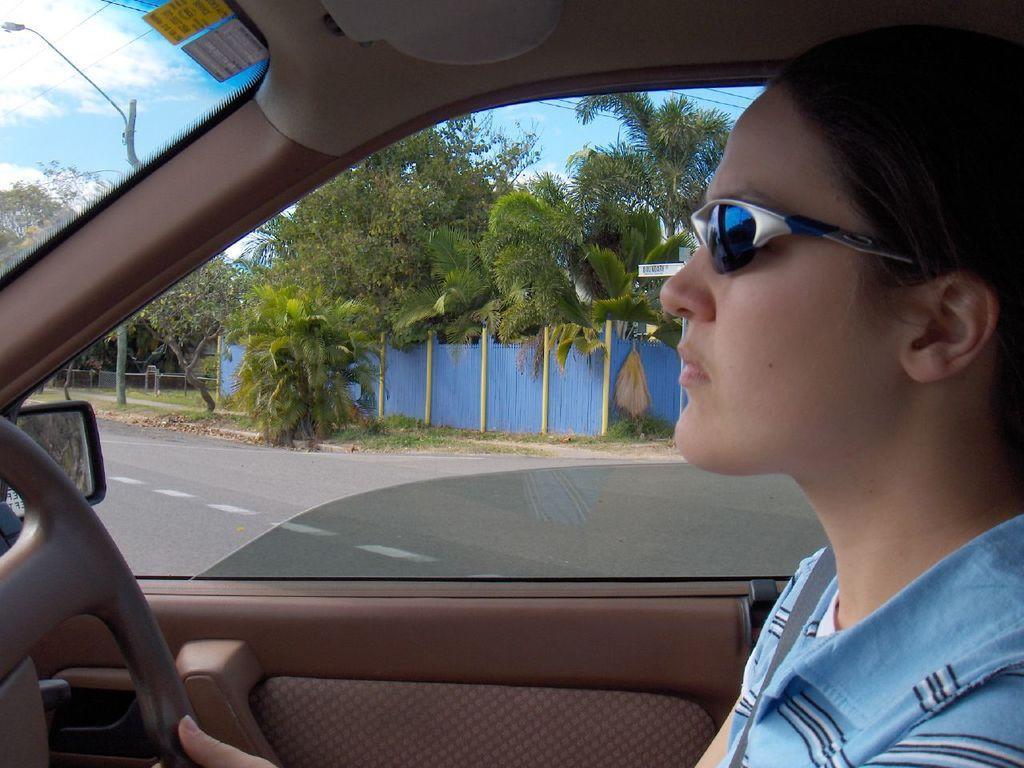How would you summarize this image in a sentence or two? a person is riding a car, wearing goggles on the road. at the back there are blue fencing and trees. 